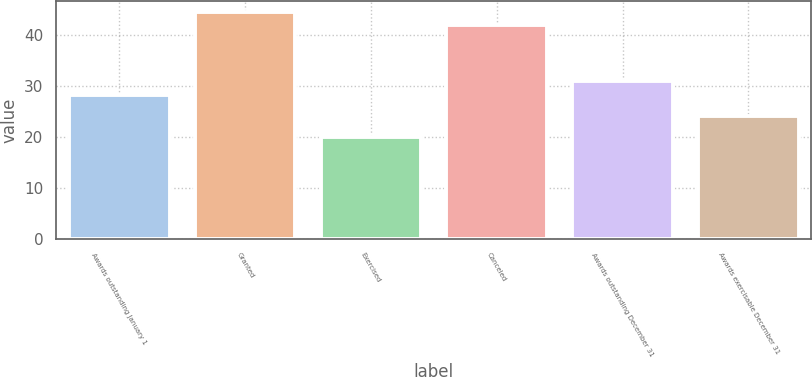<chart> <loc_0><loc_0><loc_500><loc_500><bar_chart><fcel>Awards outstanding January 1<fcel>Granted<fcel>Exercised<fcel>Canceled<fcel>Awards outstanding December 31<fcel>Awards exercisable December 31<nl><fcel>28.09<fcel>44.33<fcel>19.96<fcel>41.96<fcel>30.84<fcel>24.1<nl></chart> 